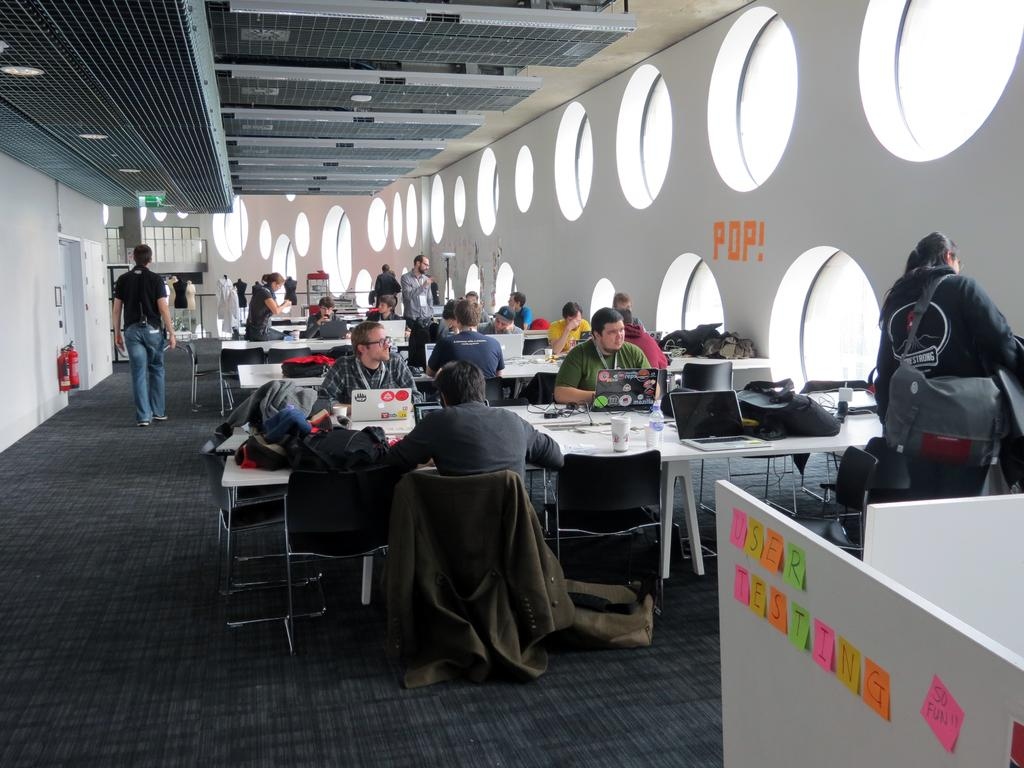<image>
Share a concise interpretation of the image provided. Notes on a wall that say there is testing going on 